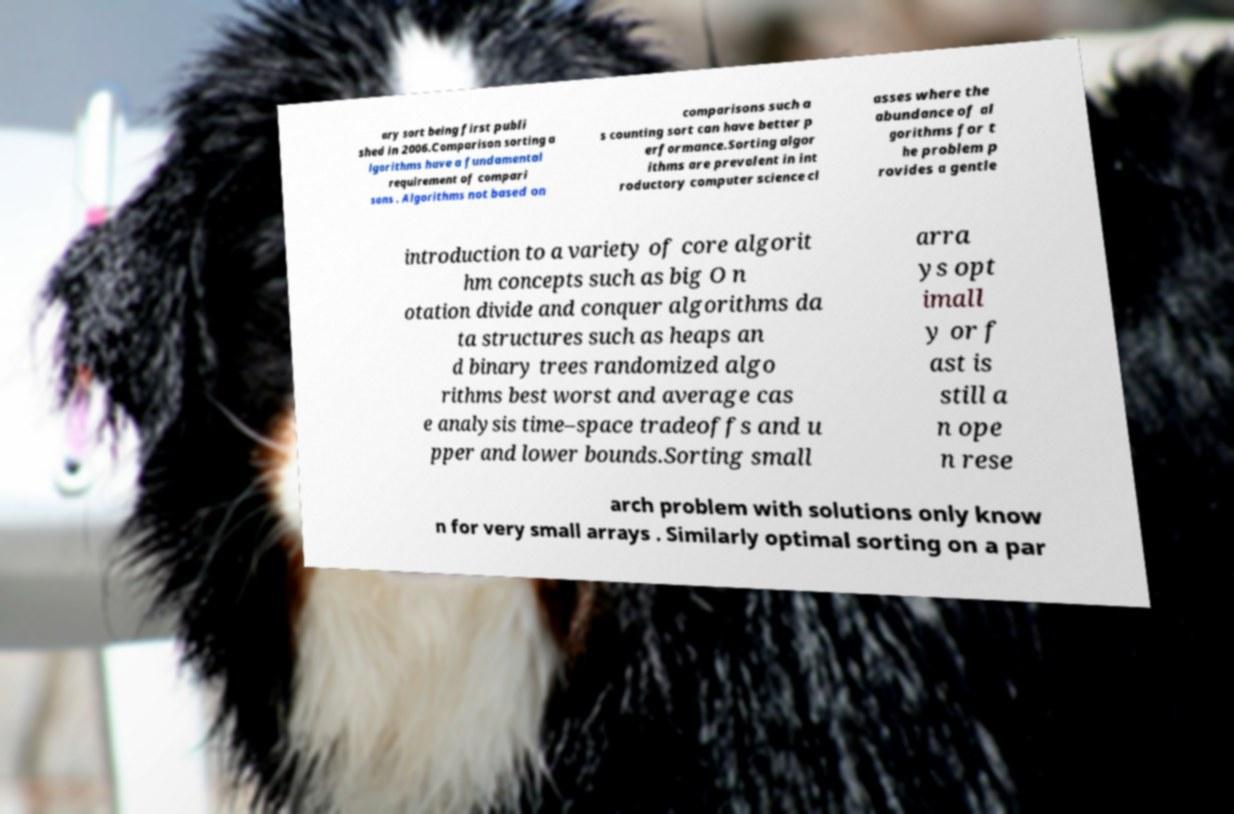Could you extract and type out the text from this image? ary sort being first publi shed in 2006.Comparison sorting a lgorithms have a fundamental requirement of compari sons . Algorithms not based on comparisons such a s counting sort can have better p erformance.Sorting algor ithms are prevalent in int roductory computer science cl asses where the abundance of al gorithms for t he problem p rovides a gentle introduction to a variety of core algorit hm concepts such as big O n otation divide and conquer algorithms da ta structures such as heaps an d binary trees randomized algo rithms best worst and average cas e analysis time–space tradeoffs and u pper and lower bounds.Sorting small arra ys opt imall y or f ast is still a n ope n rese arch problem with solutions only know n for very small arrays . Similarly optimal sorting on a par 